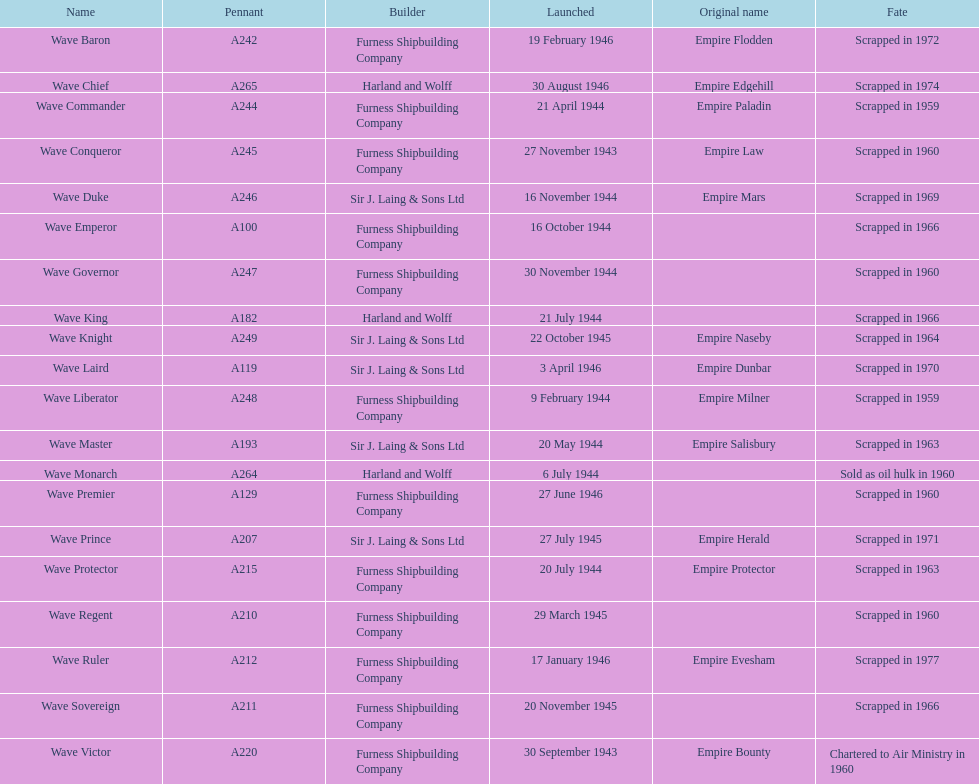Would you be able to parse every entry in this table? {'header': ['Name', 'Pennant', 'Builder', 'Launched', 'Original name', 'Fate'], 'rows': [['Wave Baron', 'A242', 'Furness Shipbuilding Company', '19 February 1946', 'Empire Flodden', 'Scrapped in 1972'], ['Wave Chief', 'A265', 'Harland and Wolff', '30 August 1946', 'Empire Edgehill', 'Scrapped in 1974'], ['Wave Commander', 'A244', 'Furness Shipbuilding Company', '21 April 1944', 'Empire Paladin', 'Scrapped in 1959'], ['Wave Conqueror', 'A245', 'Furness Shipbuilding Company', '27 November 1943', 'Empire Law', 'Scrapped in 1960'], ['Wave Duke', 'A246', 'Sir J. Laing & Sons Ltd', '16 November 1944', 'Empire Mars', 'Scrapped in 1969'], ['Wave Emperor', 'A100', 'Furness Shipbuilding Company', '16 October 1944', '', 'Scrapped in 1966'], ['Wave Governor', 'A247', 'Furness Shipbuilding Company', '30 November 1944', '', 'Scrapped in 1960'], ['Wave King', 'A182', 'Harland and Wolff', '21 July 1944', '', 'Scrapped in 1966'], ['Wave Knight', 'A249', 'Sir J. Laing & Sons Ltd', '22 October 1945', 'Empire Naseby', 'Scrapped in 1964'], ['Wave Laird', 'A119', 'Sir J. Laing & Sons Ltd', '3 April 1946', 'Empire Dunbar', 'Scrapped in 1970'], ['Wave Liberator', 'A248', 'Furness Shipbuilding Company', '9 February 1944', 'Empire Milner', 'Scrapped in 1959'], ['Wave Master', 'A193', 'Sir J. Laing & Sons Ltd', '20 May 1944', 'Empire Salisbury', 'Scrapped in 1963'], ['Wave Monarch', 'A264', 'Harland and Wolff', '6 July 1944', '', 'Sold as oil hulk in 1960'], ['Wave Premier', 'A129', 'Furness Shipbuilding Company', '27 June 1946', '', 'Scrapped in 1960'], ['Wave Prince', 'A207', 'Sir J. Laing & Sons Ltd', '27 July 1945', 'Empire Herald', 'Scrapped in 1971'], ['Wave Protector', 'A215', 'Furness Shipbuilding Company', '20 July 1944', 'Empire Protector', 'Scrapped in 1963'], ['Wave Regent', 'A210', 'Furness Shipbuilding Company', '29 March 1945', '', 'Scrapped in 1960'], ['Wave Ruler', 'A212', 'Furness Shipbuilding Company', '17 January 1946', 'Empire Evesham', 'Scrapped in 1977'], ['Wave Sovereign', 'A211', 'Furness Shipbuilding Company', '20 November 1945', '', 'Scrapped in 1966'], ['Wave Victor', 'A220', 'Furness Shipbuilding Company', '30 September 1943', 'Empire Bounty', 'Chartered to Air Ministry in 1960']]} Which other ship was launched in the same year as the wave victor? Wave Conqueror. 